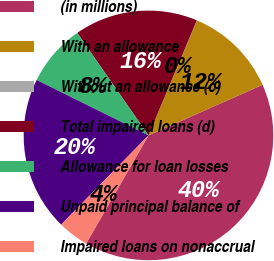Convert chart to OTSL. <chart><loc_0><loc_0><loc_500><loc_500><pie_chart><fcel>(in millions)<fcel>With an allowance<fcel>Without an allowance (c)<fcel>Total impaired loans (d)<fcel>Allowance for loan losses<fcel>Unpaid principal balance of<fcel>Impaired loans on nonaccrual<nl><fcel>39.96%<fcel>12.0%<fcel>0.02%<fcel>16.0%<fcel>8.01%<fcel>19.99%<fcel>4.01%<nl></chart> 